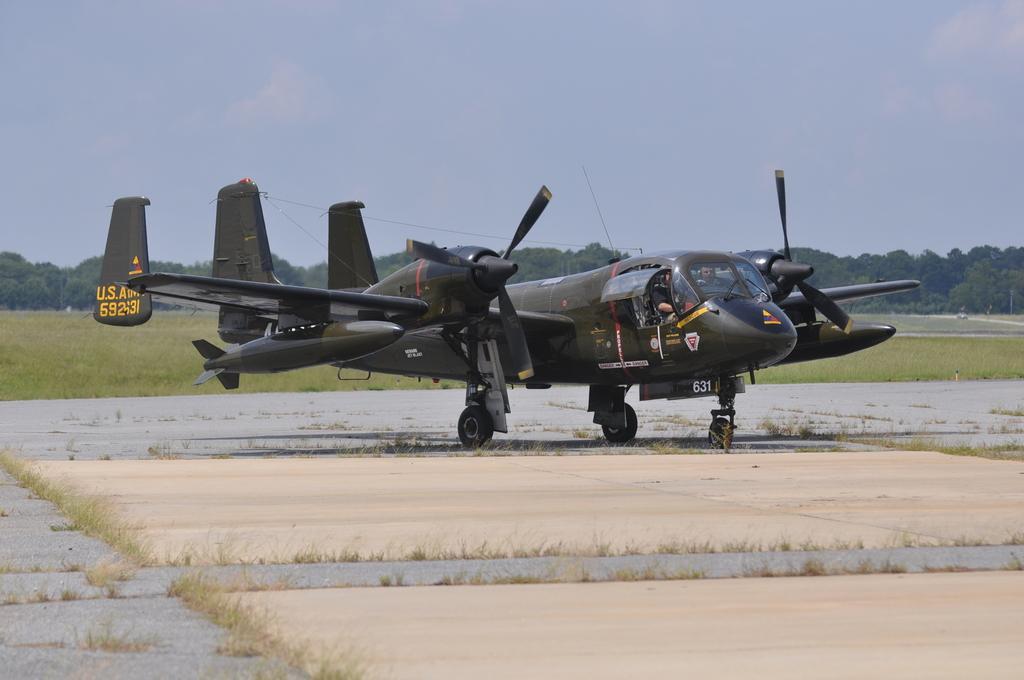Please provide a concise description of this image. In the image there is a plane on the floor. And there is grass in few places. Behind the plane on the ground there is grass. In the background there are trees. At the top of the image there is sky. 